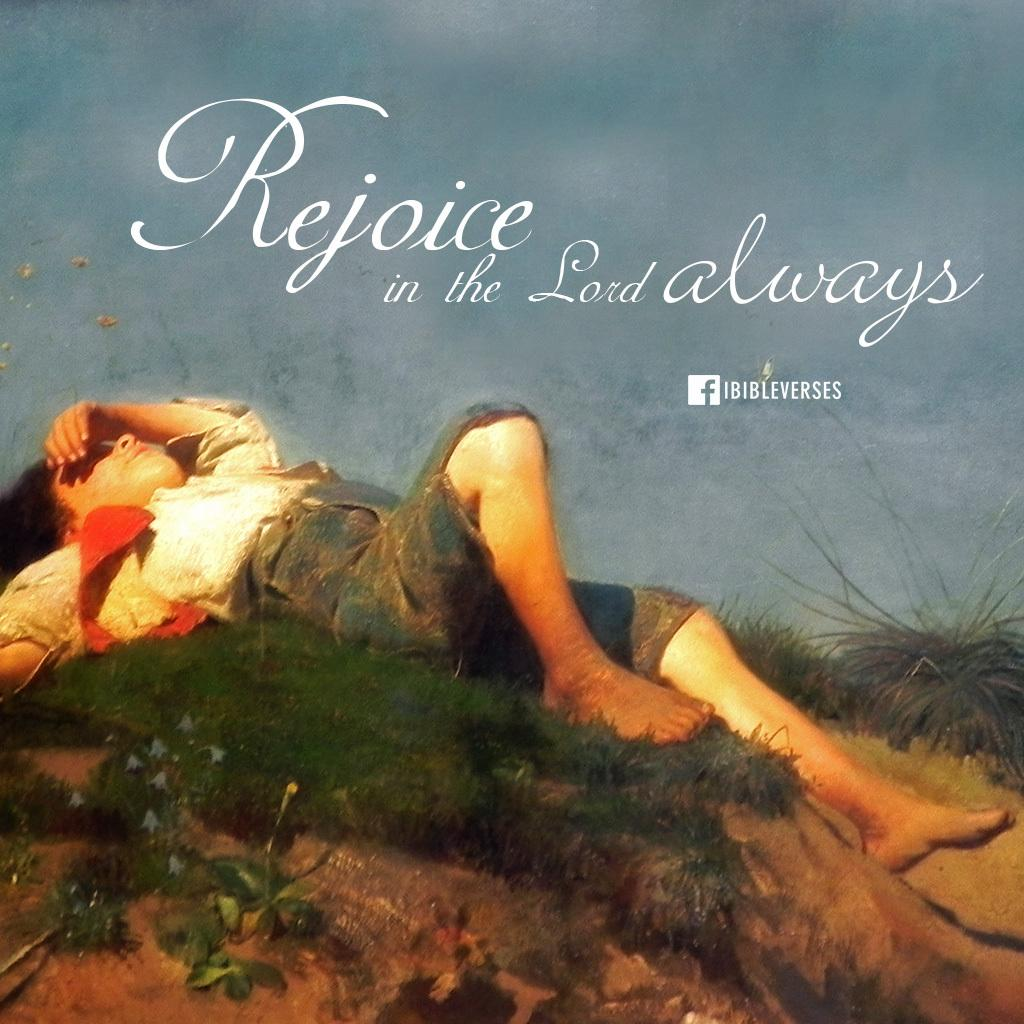<image>
Give a short and clear explanation of the subsequent image. A advertisement that says Rejoice in the Lord showing a women lying in grass looking up to the sky, 